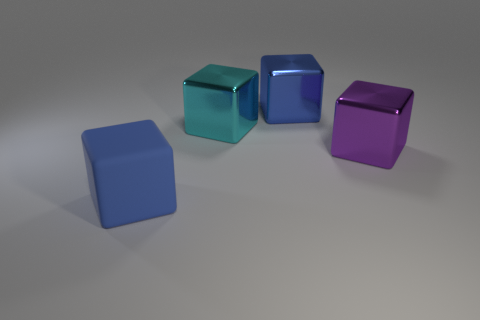The matte thing that is the same shape as the big blue shiny object is what color?
Offer a very short reply. Blue. What number of matte objects are the same color as the rubber cube?
Make the answer very short. 0. Are the large purple cube and the blue thing on the right side of the cyan thing made of the same material?
Offer a very short reply. Yes. How many large purple cubes have the same material as the large cyan object?
Provide a short and direct response. 1. What shape is the blue object that is in front of the large purple metal object?
Offer a very short reply. Cube. Do the blue thing behind the purple cube and the big cyan cube left of the big purple metallic cube have the same material?
Your response must be concise. Yes. Are there any other large shiny things that have the same shape as the big purple object?
Your answer should be compact. Yes. What number of objects are large blocks to the left of the purple metal block or red shiny spheres?
Give a very brief answer. 3. Are there more things left of the purple shiny thing than cyan objects behind the big blue shiny object?
Keep it short and to the point. Yes. What number of matte things are either cubes or big purple cubes?
Offer a terse response. 1. 